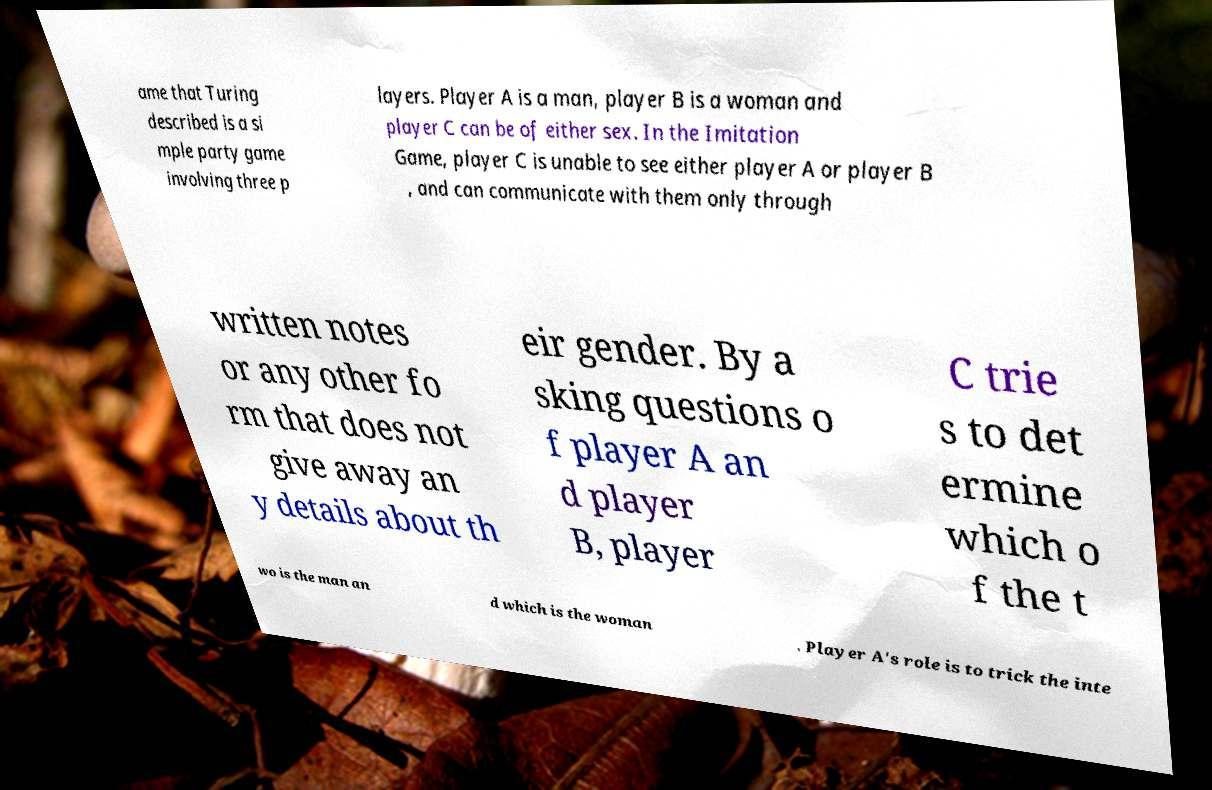For documentation purposes, I need the text within this image transcribed. Could you provide that? ame that Turing described is a si mple party game involving three p layers. Player A is a man, player B is a woman and player C can be of either sex. In the Imitation Game, player C is unable to see either player A or player B , and can communicate with them only through written notes or any other fo rm that does not give away an y details about th eir gender. By a sking questions o f player A an d player B, player C trie s to det ermine which o f the t wo is the man an d which is the woman . Player A's role is to trick the inte 